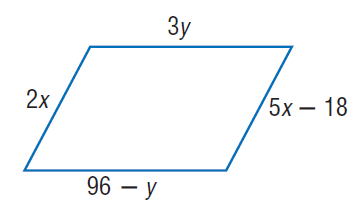Question: Find x so that the quadrilateral is a parallelogram.
Choices:
A. 6
B. 12
C. 24
D. 30
Answer with the letter. Answer: A Question: Find y so that the quadrilateral is a parallelogram.
Choices:
A. 12
B. 24
C. 48
D. 72
Answer with the letter. Answer: B 